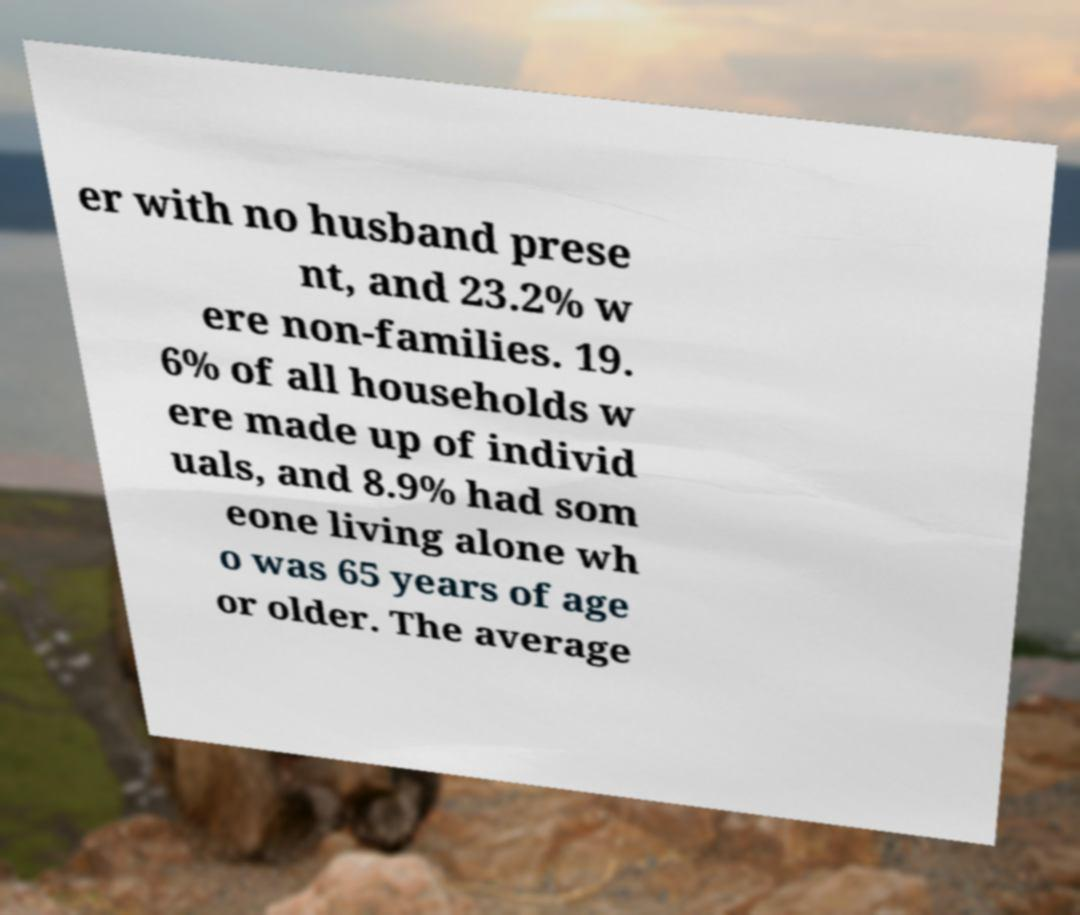Could you assist in decoding the text presented in this image and type it out clearly? er with no husband prese nt, and 23.2% w ere non-families. 19. 6% of all households w ere made up of individ uals, and 8.9% had som eone living alone wh o was 65 years of age or older. The average 